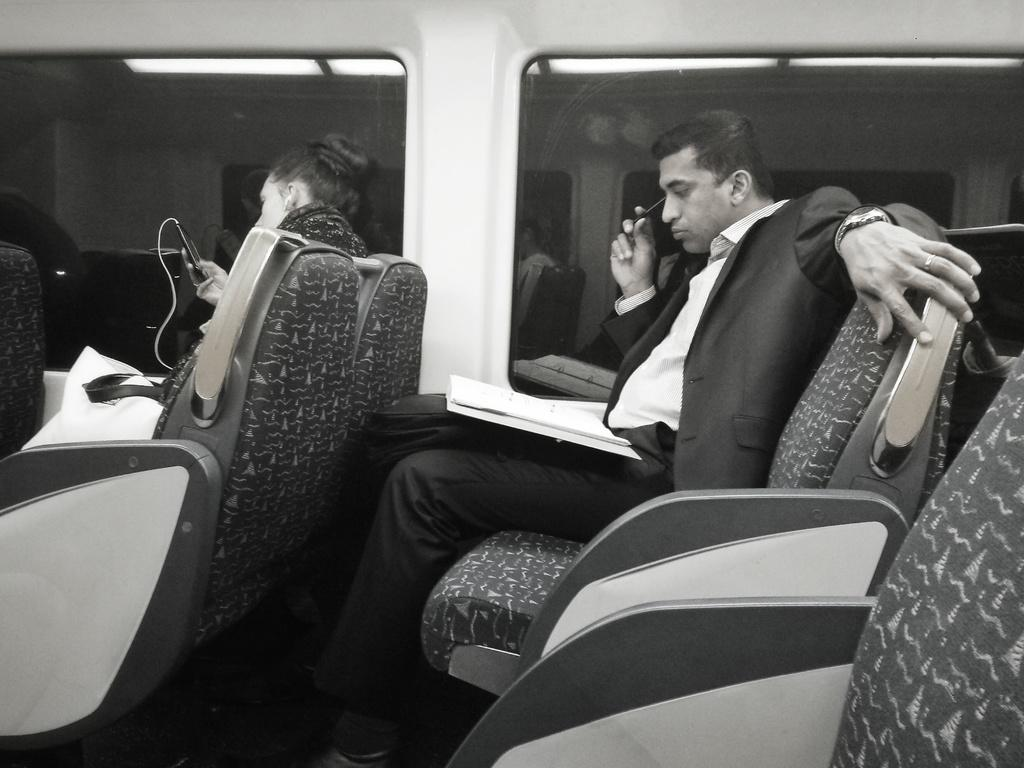How many people are sitting in the image? There are two people sitting on seats in the image. What object can be seen near the people? There is a bookbag in the image. What electronic device is present in the image? There is a mobile in the image. What type of material is visible in the background of the image? There is glass in the background of the image. What can be seen illuminating the background of the image? There are lights in the background of the image. What type of servant is present in the image? There is no servant present in the image. What can be seen coming out of the mouth of the person on the left? There is no mouth visible in the image, as the people are sitting and their faces are not shown. 